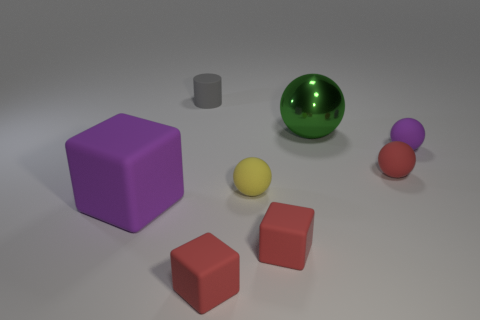Subtract all purple balls. How many balls are left? 3 Subtract all small purple matte balls. How many balls are left? 3 Add 1 blue metal blocks. How many objects exist? 9 Subtract all blocks. How many objects are left? 5 Subtract 4 spheres. How many spheres are left? 0 Subtract all gray blocks. How many yellow cylinders are left? 0 Subtract all big purple metallic cylinders. Subtract all matte things. How many objects are left? 1 Add 3 big green metallic balls. How many big green metallic balls are left? 4 Add 8 small gray matte things. How many small gray matte things exist? 9 Subtract 0 blue cylinders. How many objects are left? 8 